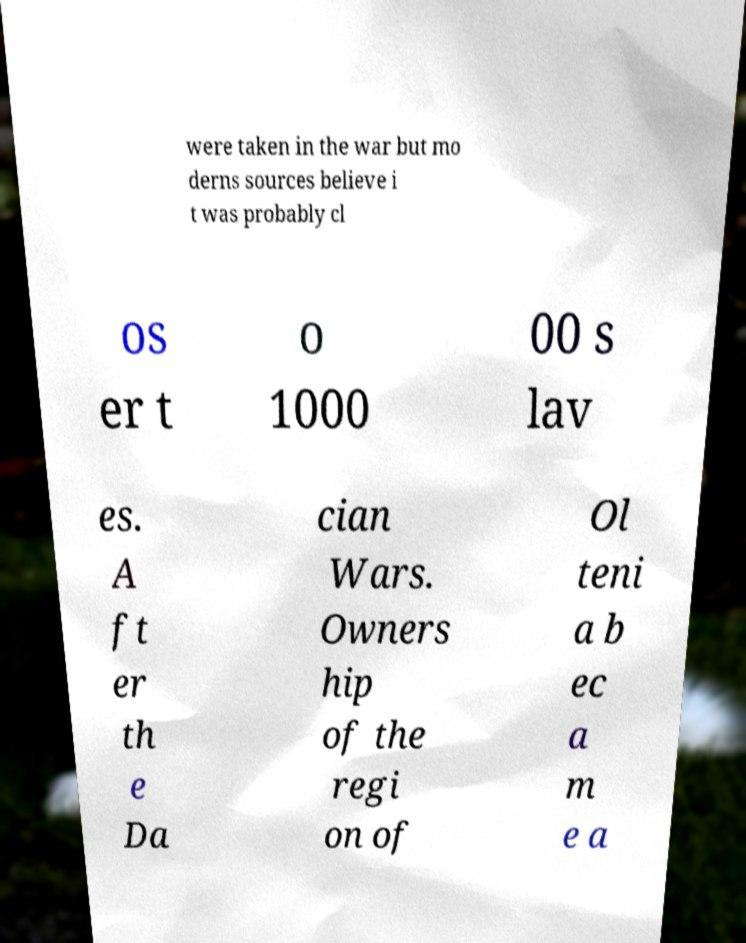Can you accurately transcribe the text from the provided image for me? were taken in the war but mo derns sources believe i t was probably cl os er t o 1000 00 s lav es. A ft er th e Da cian Wars. Owners hip of the regi on of Ol teni a b ec a m e a 